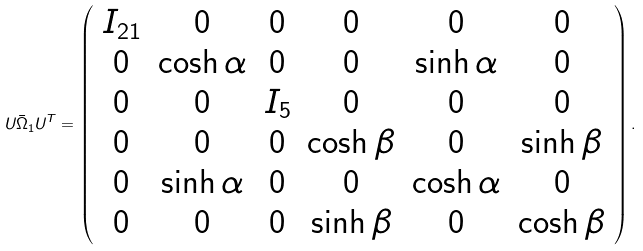Convert formula to latex. <formula><loc_0><loc_0><loc_500><loc_500>U \bar { \Omega } _ { 1 } U ^ { T } = \left ( \begin{array} { c c c c c c } I _ { 2 1 } & 0 & 0 & 0 & 0 & 0 \\ 0 & \cosh \alpha & 0 & 0 & \sinh \alpha & 0 \\ 0 & 0 & I _ { 5 } & 0 & 0 & 0 \\ 0 & 0 & 0 & \cosh \beta & 0 & \sinh \beta \\ 0 & \sinh \alpha & 0 & 0 & \cosh \alpha & 0 \\ 0 & 0 & 0 & \sinh \beta & 0 & \cosh \beta \\ \end{array} \right ) . \\</formula> 